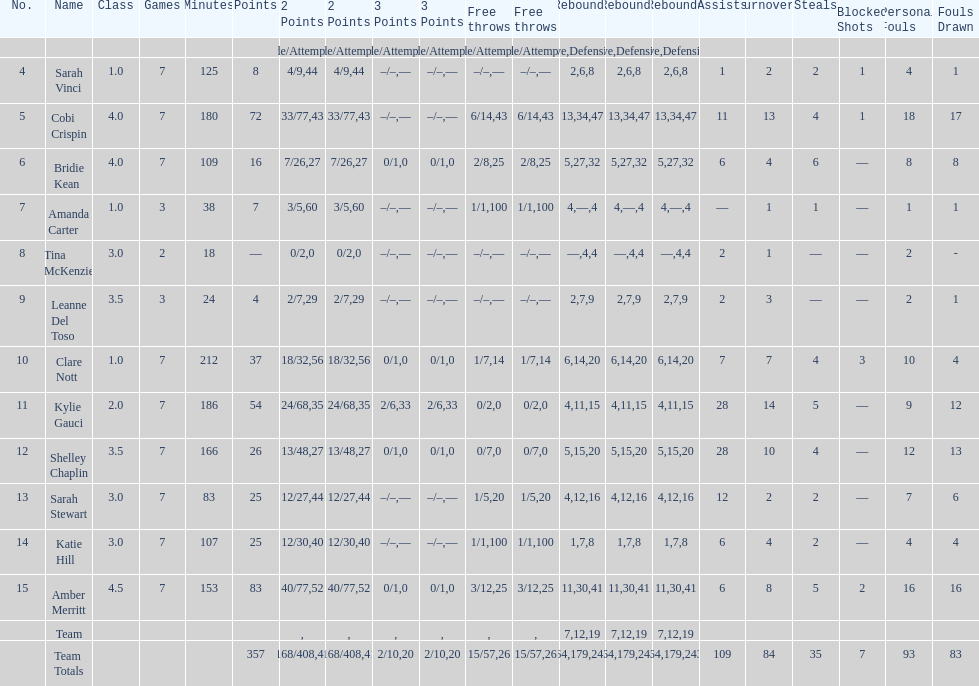Following seven matches, how many individuals had over 30 points? 4. 